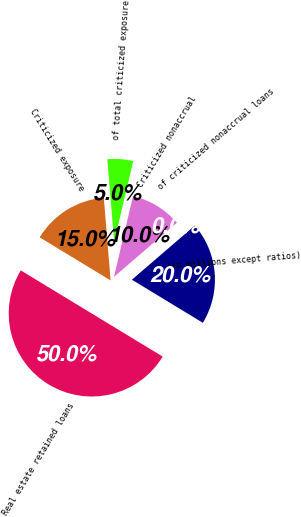<chart> <loc_0><loc_0><loc_500><loc_500><pie_chart><fcel>(in millions except ratios)<fcel>Real estate retained loans<fcel>Criticized exposure<fcel>of total criticized exposure<fcel>Criticized nonaccrual<fcel>of criticized nonaccrual loans<nl><fcel>20.0%<fcel>50.0%<fcel>15.0%<fcel>5.0%<fcel>10.0%<fcel>0.0%<nl></chart> 